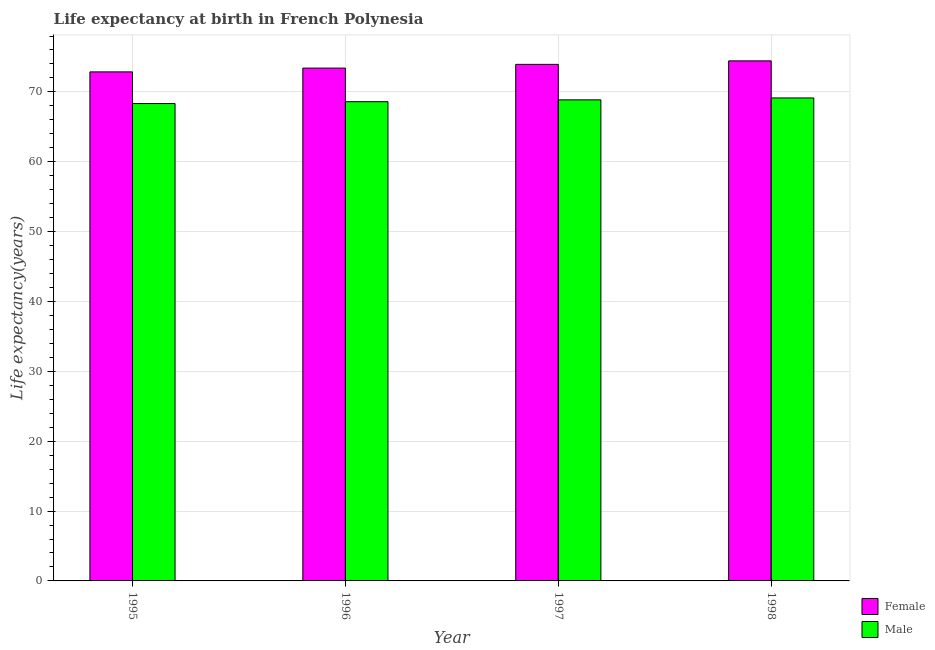Are the number of bars on each tick of the X-axis equal?
Offer a terse response. Yes. How many bars are there on the 4th tick from the right?
Your answer should be compact. 2. What is the life expectancy(female) in 1996?
Keep it short and to the point. 73.41. Across all years, what is the maximum life expectancy(male)?
Keep it short and to the point. 69.14. Across all years, what is the minimum life expectancy(male)?
Give a very brief answer. 68.33. What is the total life expectancy(female) in the graph?
Provide a succinct answer. 294.65. What is the difference between the life expectancy(female) in 1995 and that in 1997?
Offer a very short reply. -1.08. What is the difference between the life expectancy(female) in 1996 and the life expectancy(male) in 1997?
Offer a very short reply. -0.53. What is the average life expectancy(female) per year?
Keep it short and to the point. 73.66. In the year 1997, what is the difference between the life expectancy(male) and life expectancy(female)?
Your answer should be very brief. 0. What is the ratio of the life expectancy(male) in 1995 to that in 1997?
Provide a succinct answer. 0.99. What is the difference between the highest and the second highest life expectancy(male)?
Offer a terse response. 0.28. What is the difference between the highest and the lowest life expectancy(female)?
Your response must be concise. 1.58. In how many years, is the life expectancy(male) greater than the average life expectancy(male) taken over all years?
Keep it short and to the point. 2. What does the 1st bar from the left in 1997 represents?
Give a very brief answer. Female. What does the 2nd bar from the right in 1995 represents?
Offer a terse response. Female. How many years are there in the graph?
Give a very brief answer. 4. How many legend labels are there?
Ensure brevity in your answer.  2. How are the legend labels stacked?
Your answer should be compact. Vertical. What is the title of the graph?
Provide a succinct answer. Life expectancy at birth in French Polynesia. What is the label or title of the Y-axis?
Give a very brief answer. Life expectancy(years). What is the Life expectancy(years) in Female in 1995?
Your answer should be compact. 72.87. What is the Life expectancy(years) of Male in 1995?
Keep it short and to the point. 68.33. What is the Life expectancy(years) of Female in 1996?
Your response must be concise. 73.41. What is the Life expectancy(years) of Male in 1996?
Provide a short and direct response. 68.6. What is the Life expectancy(years) of Female in 1997?
Provide a short and direct response. 73.94. What is the Life expectancy(years) in Male in 1997?
Make the answer very short. 68.86. What is the Life expectancy(years) in Female in 1998?
Your answer should be very brief. 74.44. What is the Life expectancy(years) of Male in 1998?
Give a very brief answer. 69.14. Across all years, what is the maximum Life expectancy(years) in Female?
Ensure brevity in your answer.  74.44. Across all years, what is the maximum Life expectancy(years) of Male?
Make the answer very short. 69.14. Across all years, what is the minimum Life expectancy(years) of Female?
Provide a succinct answer. 72.87. Across all years, what is the minimum Life expectancy(years) of Male?
Your answer should be very brief. 68.33. What is the total Life expectancy(years) of Female in the graph?
Your answer should be compact. 294.65. What is the total Life expectancy(years) of Male in the graph?
Your answer should be compact. 274.93. What is the difference between the Life expectancy(years) of Female in 1995 and that in 1996?
Offer a very short reply. -0.54. What is the difference between the Life expectancy(years) of Male in 1995 and that in 1996?
Provide a succinct answer. -0.27. What is the difference between the Life expectancy(years) of Female in 1995 and that in 1997?
Provide a succinct answer. -1.07. What is the difference between the Life expectancy(years) of Male in 1995 and that in 1997?
Provide a short and direct response. -0.53. What is the difference between the Life expectancy(years) of Female in 1995 and that in 1998?
Offer a very short reply. -1.57. What is the difference between the Life expectancy(years) in Male in 1995 and that in 1998?
Provide a short and direct response. -0.8. What is the difference between the Life expectancy(years) in Female in 1996 and that in 1997?
Keep it short and to the point. -0.54. What is the difference between the Life expectancy(years) of Male in 1996 and that in 1997?
Keep it short and to the point. -0.26. What is the difference between the Life expectancy(years) of Female in 1996 and that in 1998?
Your response must be concise. -1.03. What is the difference between the Life expectancy(years) in Male in 1996 and that in 1998?
Provide a succinct answer. -0.54. What is the difference between the Life expectancy(years) in Female in 1997 and that in 1998?
Provide a short and direct response. -0.5. What is the difference between the Life expectancy(years) in Male in 1997 and that in 1998?
Give a very brief answer. -0.28. What is the difference between the Life expectancy(years) in Female in 1995 and the Life expectancy(years) in Male in 1996?
Offer a terse response. 4.27. What is the difference between the Life expectancy(years) in Female in 1995 and the Life expectancy(years) in Male in 1997?
Your response must be concise. 4. What is the difference between the Life expectancy(years) in Female in 1995 and the Life expectancy(years) in Male in 1998?
Your answer should be compact. 3.73. What is the difference between the Life expectancy(years) of Female in 1996 and the Life expectancy(years) of Male in 1997?
Ensure brevity in your answer.  4.54. What is the difference between the Life expectancy(years) in Female in 1996 and the Life expectancy(years) in Male in 1998?
Offer a terse response. 4.27. What is the difference between the Life expectancy(years) in Female in 1997 and the Life expectancy(years) in Male in 1998?
Your answer should be compact. 4.8. What is the average Life expectancy(years) in Female per year?
Ensure brevity in your answer.  73.66. What is the average Life expectancy(years) of Male per year?
Keep it short and to the point. 68.73. In the year 1995, what is the difference between the Life expectancy(years) of Female and Life expectancy(years) of Male?
Offer a very short reply. 4.53. In the year 1996, what is the difference between the Life expectancy(years) of Female and Life expectancy(years) of Male?
Offer a very short reply. 4.81. In the year 1997, what is the difference between the Life expectancy(years) in Female and Life expectancy(years) in Male?
Provide a short and direct response. 5.08. In the year 1998, what is the difference between the Life expectancy(years) in Female and Life expectancy(years) in Male?
Ensure brevity in your answer.  5.3. What is the ratio of the Life expectancy(years) in Female in 1995 to that in 1996?
Your response must be concise. 0.99. What is the ratio of the Life expectancy(years) of Male in 1995 to that in 1996?
Provide a short and direct response. 1. What is the ratio of the Life expectancy(years) of Female in 1995 to that in 1997?
Provide a succinct answer. 0.99. What is the ratio of the Life expectancy(years) in Male in 1995 to that in 1997?
Give a very brief answer. 0.99. What is the ratio of the Life expectancy(years) of Female in 1995 to that in 1998?
Your response must be concise. 0.98. What is the ratio of the Life expectancy(years) of Male in 1995 to that in 1998?
Offer a very short reply. 0.99. What is the ratio of the Life expectancy(years) of Female in 1996 to that in 1997?
Offer a very short reply. 0.99. What is the ratio of the Life expectancy(years) in Male in 1996 to that in 1997?
Keep it short and to the point. 1. What is the ratio of the Life expectancy(years) of Female in 1996 to that in 1998?
Your response must be concise. 0.99. What is the ratio of the Life expectancy(years) in Male in 1997 to that in 1998?
Your answer should be very brief. 1. What is the difference between the highest and the second highest Life expectancy(years) in Female?
Your answer should be very brief. 0.5. What is the difference between the highest and the second highest Life expectancy(years) in Male?
Provide a succinct answer. 0.28. What is the difference between the highest and the lowest Life expectancy(years) in Female?
Offer a terse response. 1.57. What is the difference between the highest and the lowest Life expectancy(years) of Male?
Your response must be concise. 0.8. 